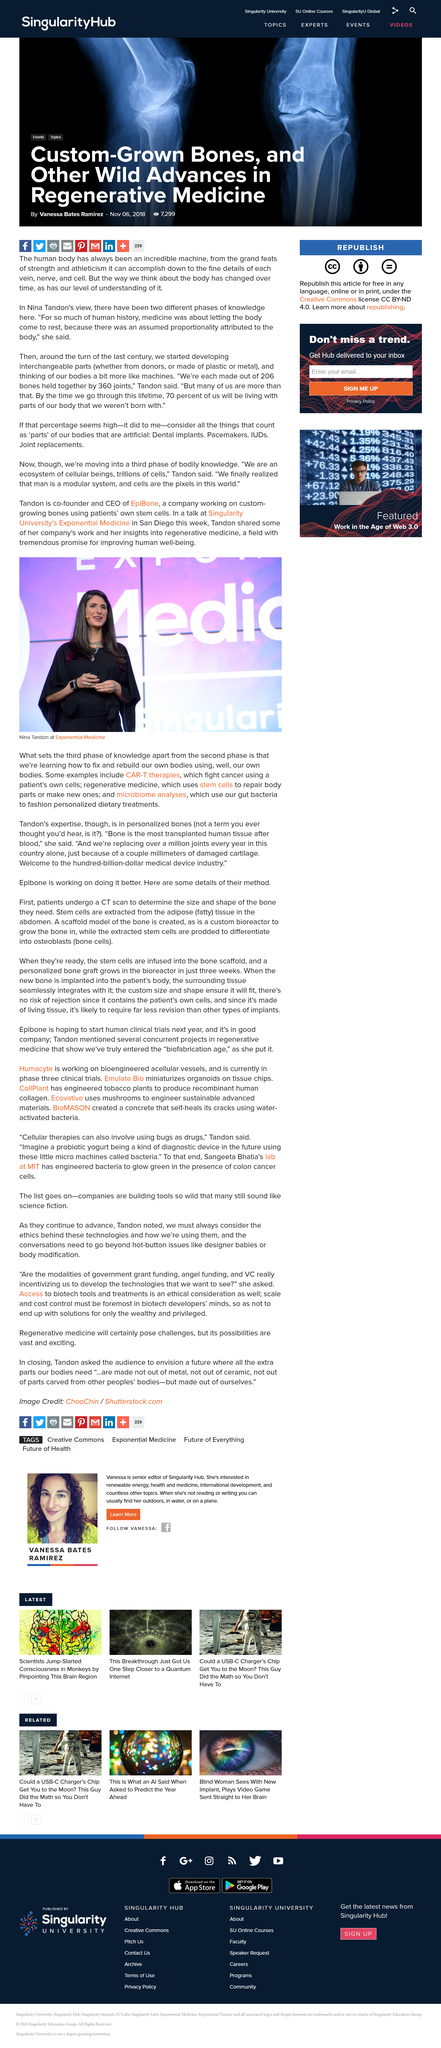Indicate a few pertinent items in this graphic. Nina Tandon is present in the picture taken at Exponential Medicine. Microbiome analyses use gut bacteria to fashion personalized dietary treatments. In the photograph, Nina Tandon can be observed. 